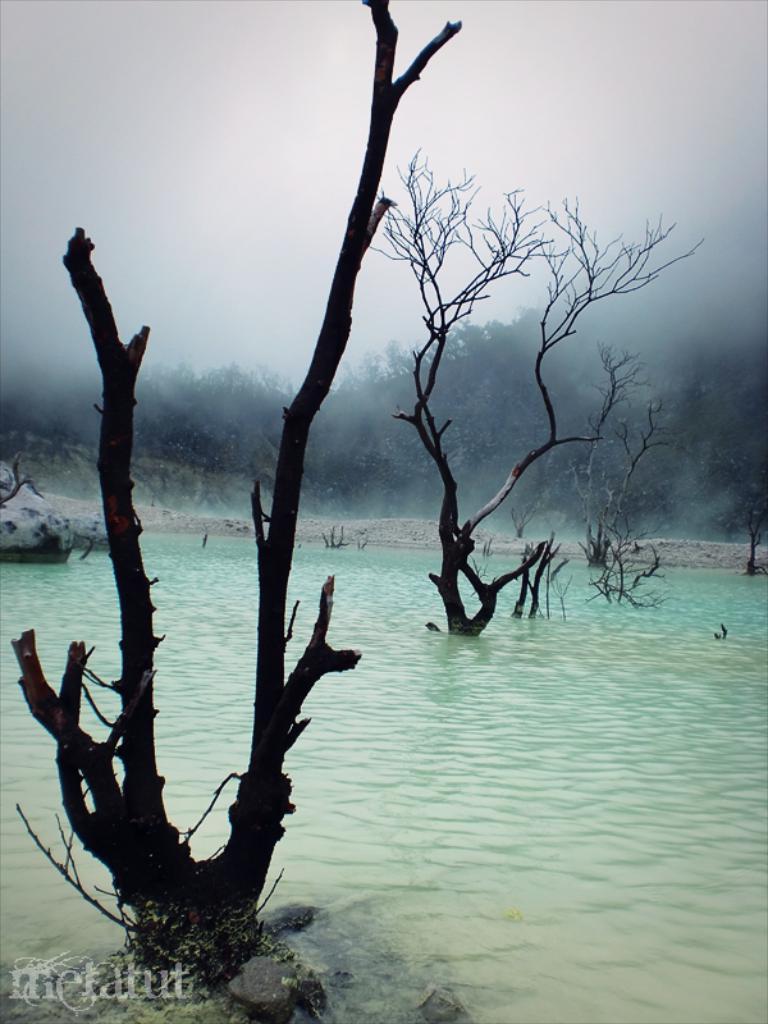Could you give a brief overview of what you see in this image? In this picture we can see trees, water and cloudy sky. Left side bottom of the image there is a watermark. 